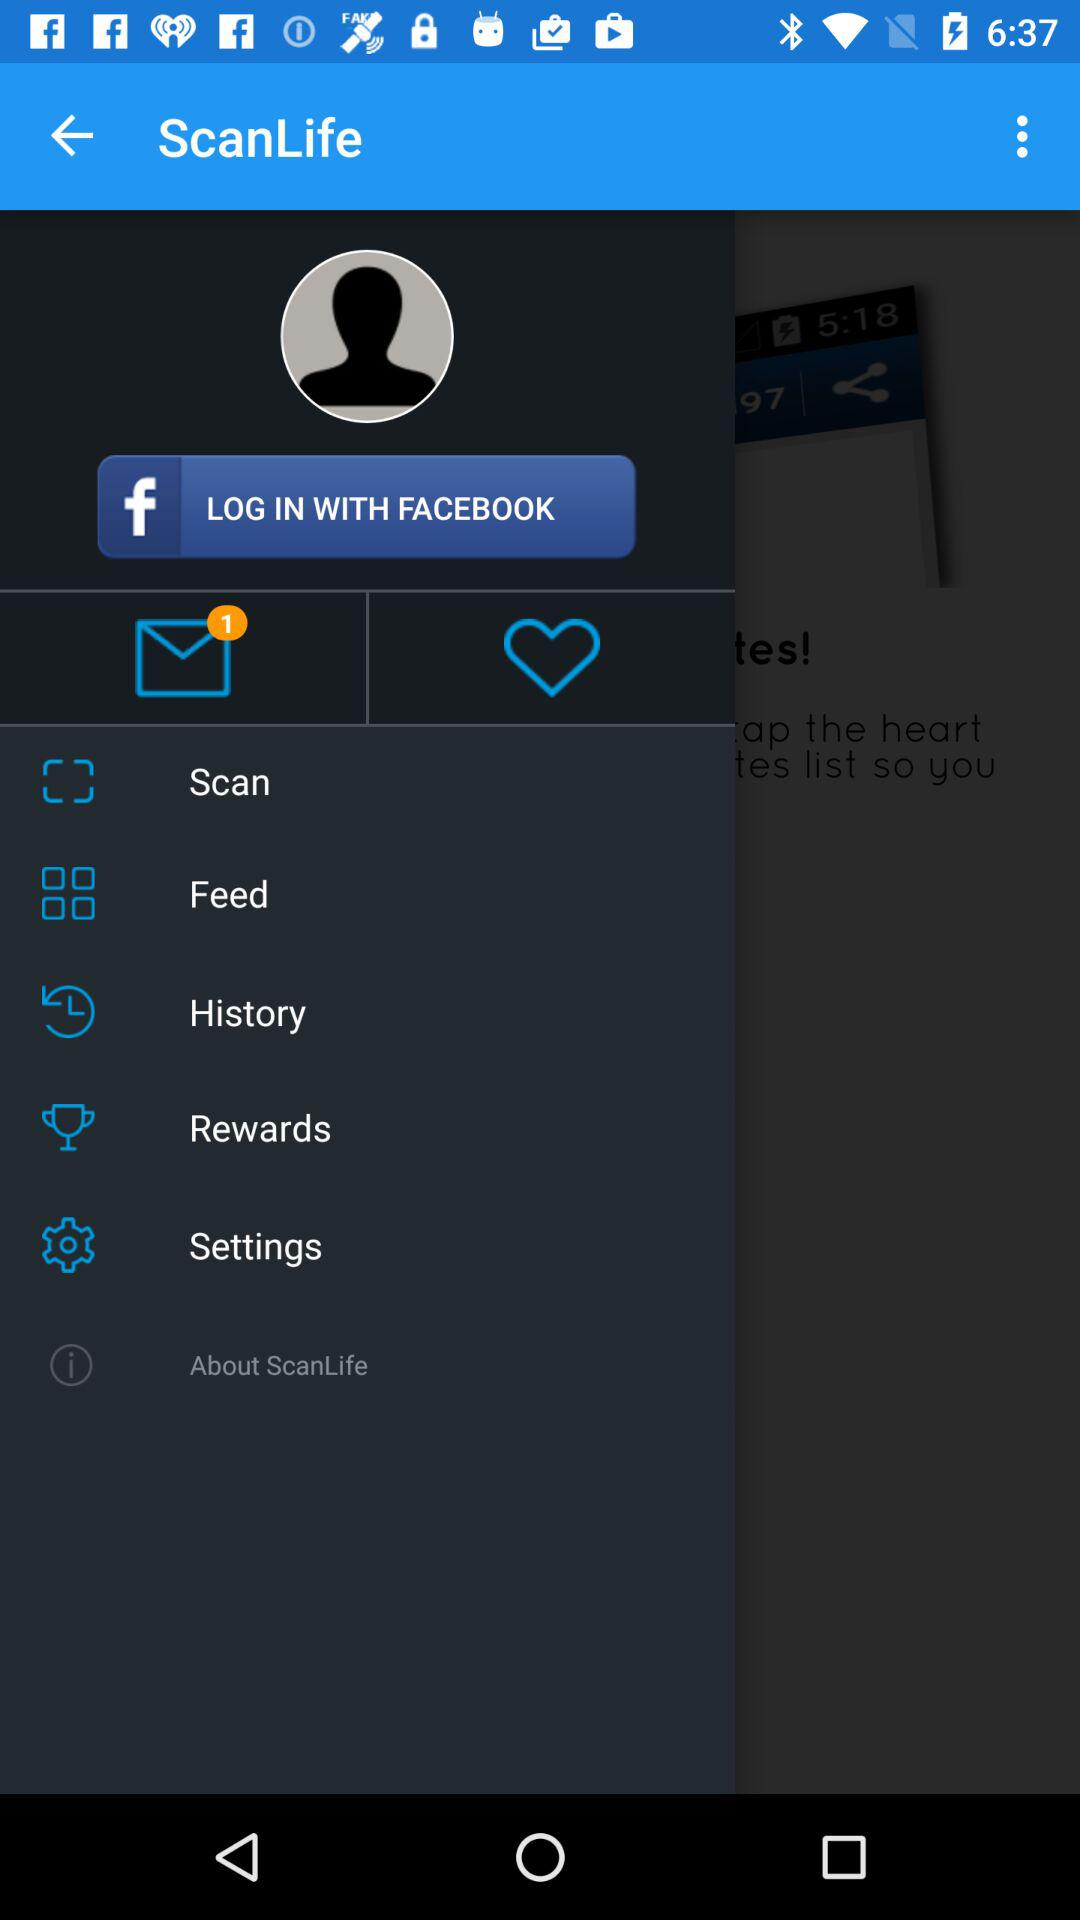What is the name of the application? The name of the application is "ScanLife". 